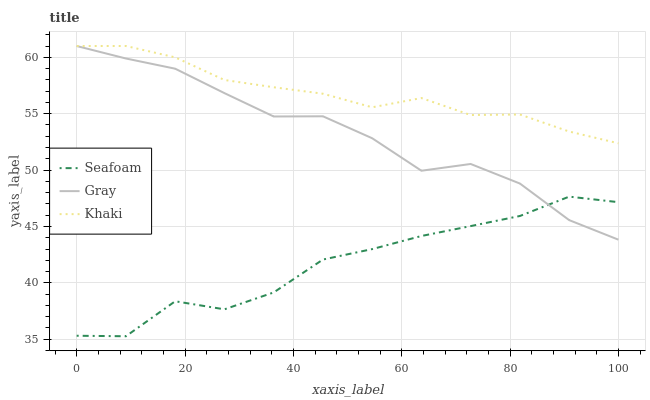Does Seafoam have the minimum area under the curve?
Answer yes or no. Yes. Does Khaki have the maximum area under the curve?
Answer yes or no. Yes. Does Khaki have the minimum area under the curve?
Answer yes or no. No. Does Seafoam have the maximum area under the curve?
Answer yes or no. No. Is Khaki the smoothest?
Answer yes or no. Yes. Is Seafoam the roughest?
Answer yes or no. Yes. Is Seafoam the smoothest?
Answer yes or no. No. Is Khaki the roughest?
Answer yes or no. No. Does Khaki have the lowest value?
Answer yes or no. No. Does Khaki have the highest value?
Answer yes or no. Yes. Does Seafoam have the highest value?
Answer yes or no. No. Is Seafoam less than Khaki?
Answer yes or no. Yes. Is Khaki greater than Seafoam?
Answer yes or no. Yes. Does Gray intersect Seafoam?
Answer yes or no. Yes. Is Gray less than Seafoam?
Answer yes or no. No. Is Gray greater than Seafoam?
Answer yes or no. No. Does Seafoam intersect Khaki?
Answer yes or no. No. 